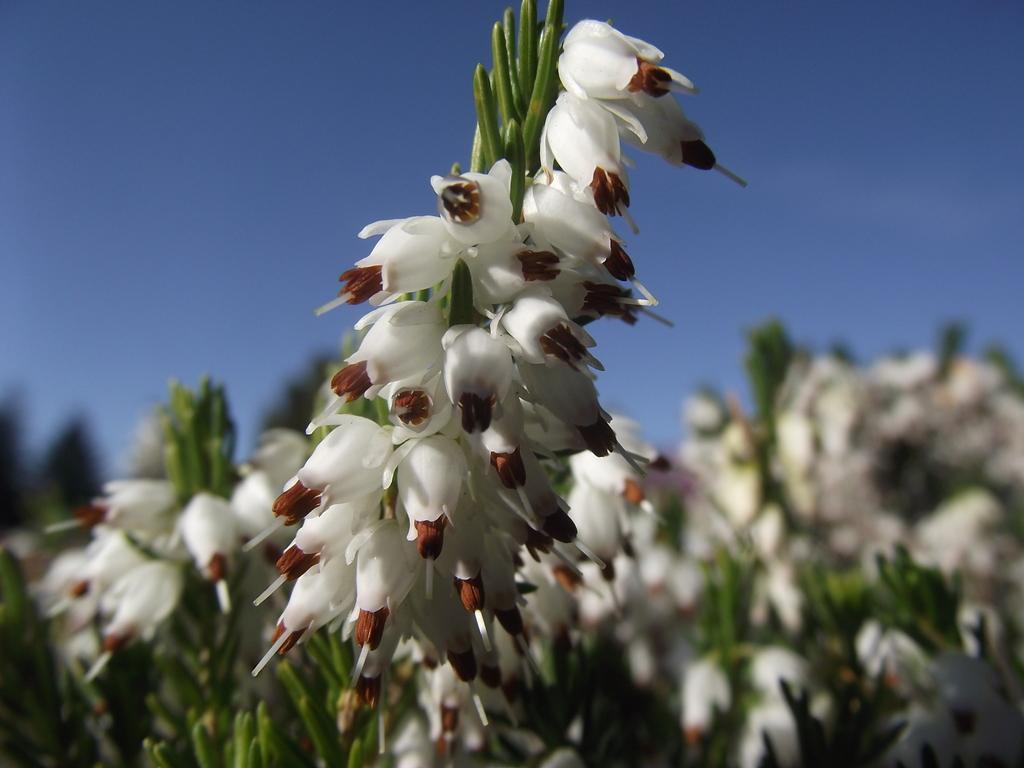What color are the flowers on the plants in the image? The flowers on the plants in the image are white. How many masses can be seen in the image? There is no mention of a mass or any religious gathering in the image; it features white color flowers on plants. 